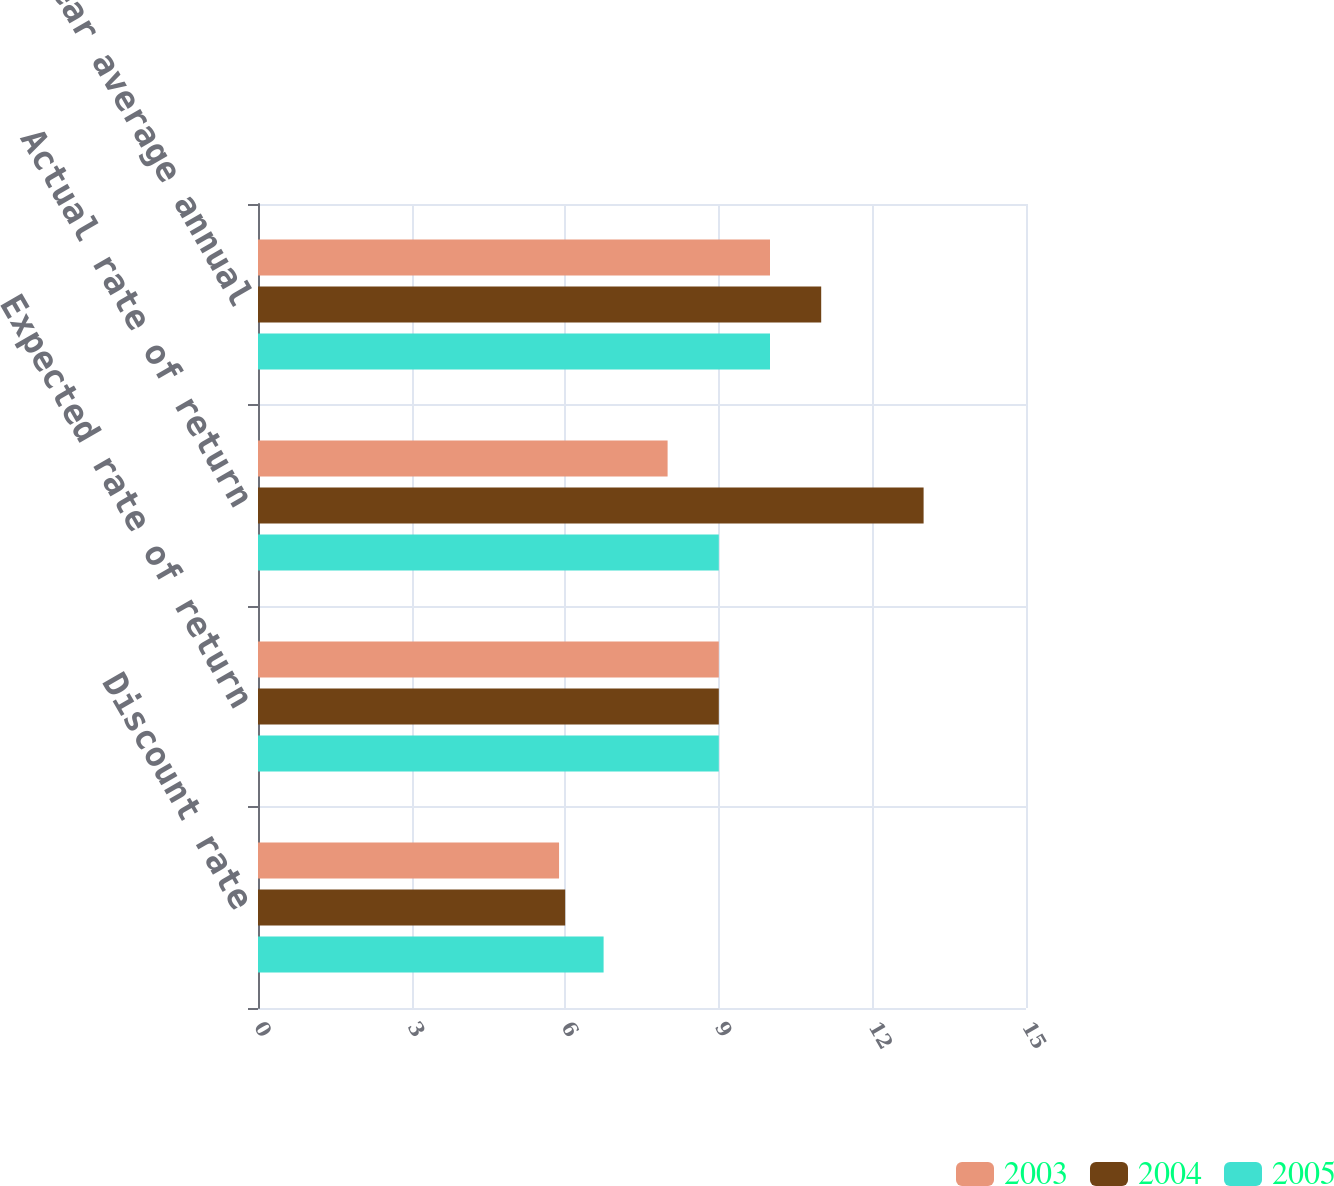Convert chart. <chart><loc_0><loc_0><loc_500><loc_500><stacked_bar_chart><ecel><fcel>Discount rate<fcel>Expected rate of return<fcel>Actual rate of return<fcel>Actual 10 year average annual<nl><fcel>2003<fcel>5.88<fcel>9<fcel>8<fcel>10<nl><fcel>2004<fcel>6<fcel>9<fcel>13<fcel>11<nl><fcel>2005<fcel>6.75<fcel>9<fcel>9<fcel>10<nl></chart> 